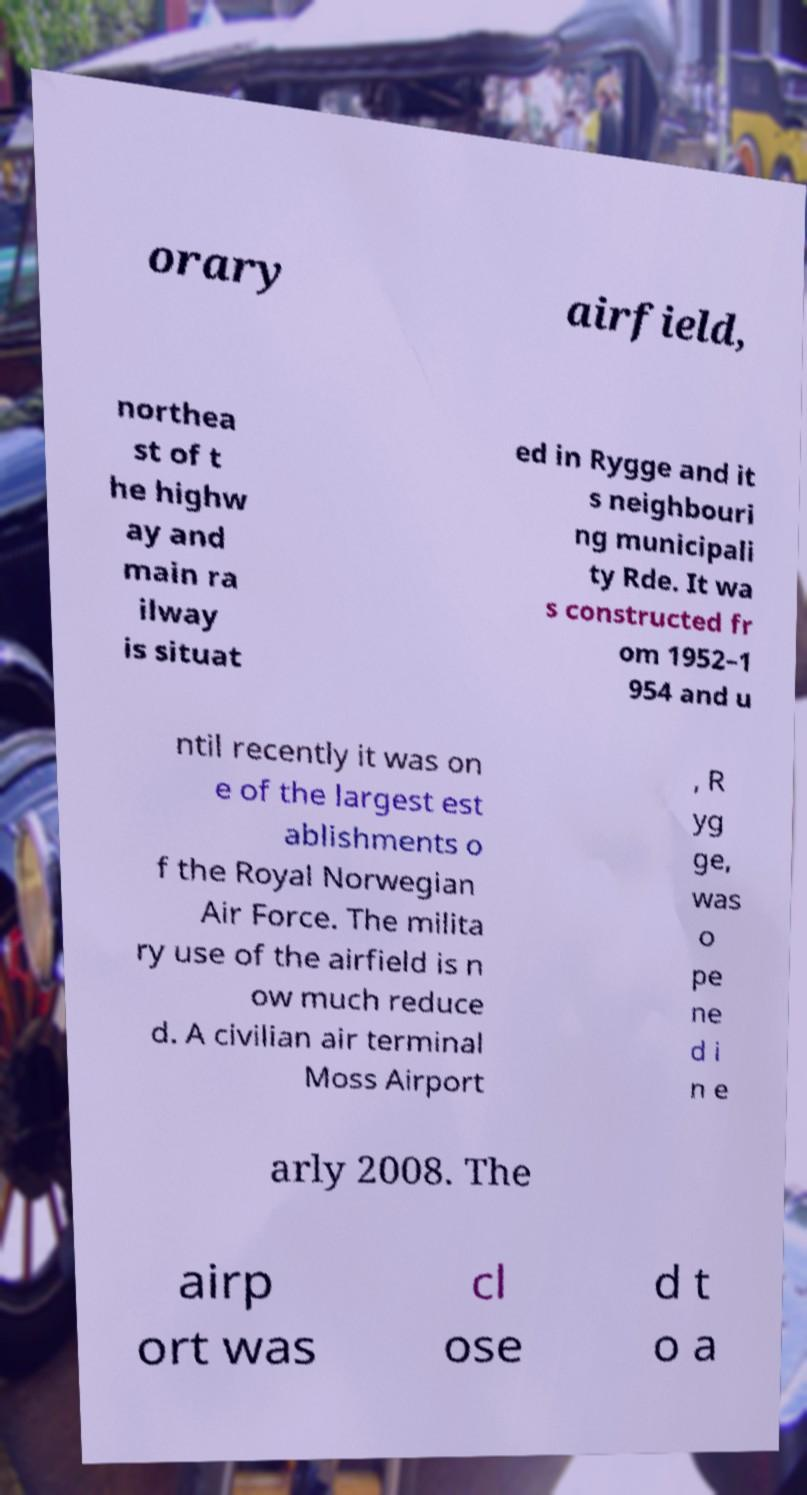Please read and relay the text visible in this image. What does it say? orary airfield, northea st of t he highw ay and main ra ilway is situat ed in Rygge and it s neighbouri ng municipali ty Rde. It wa s constructed fr om 1952–1 954 and u ntil recently it was on e of the largest est ablishments o f the Royal Norwegian Air Force. The milita ry use of the airfield is n ow much reduce d. A civilian air terminal Moss Airport , R yg ge, was o pe ne d i n e arly 2008. The airp ort was cl ose d t o a 